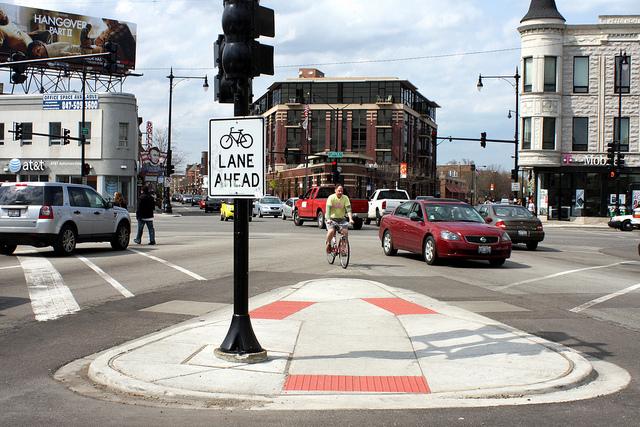What does the sign say?
Be succinct. Lane ahead. Is the billboard advertising a movie?
Concise answer only. Yes. What two communication companies have stores at this intersection?
Give a very brief answer. T mobile and at&t. 